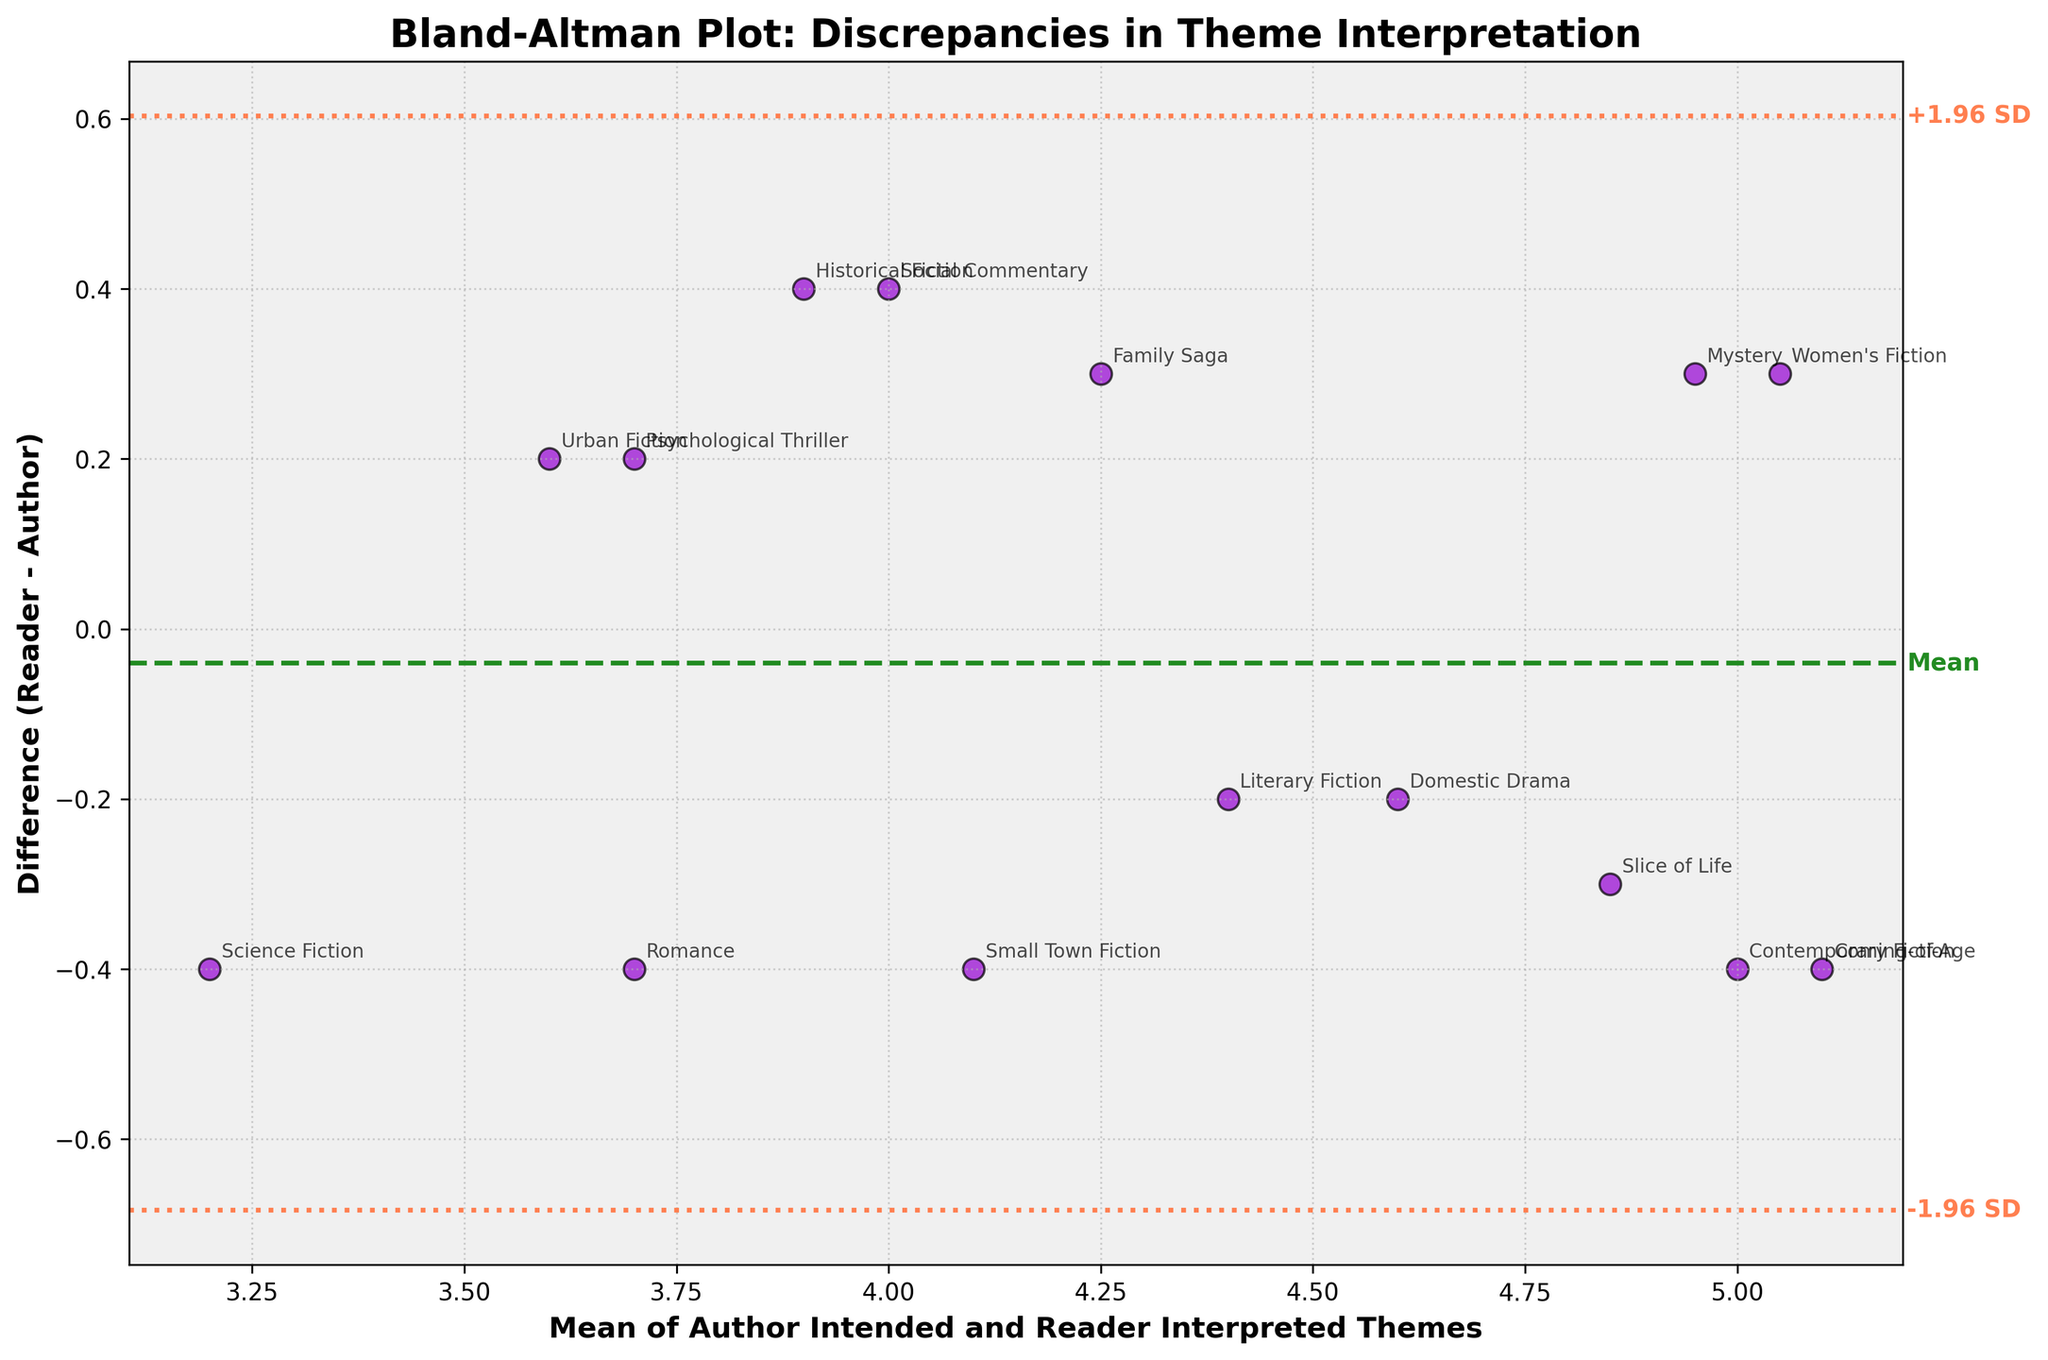What is the title of the Bland-Altman plot? The title of the Bland-Altman plot appears at the top center and is written in a large, bold font. By looking directly at the center top, you can read the full title of the plot.
Answer: Bland-Altman Plot: Discrepancies in Theme Interpretation What does the x-axis represent in the plot? The x-axis is labeled, and by reading the label, we can understand what it represents. The label is "Mean of Author Intended and Reader Interpreted Themes," indicating it shows the average value between the author's intended theme score and the reader's interpreted theme score.
Answer: Mean of Author Intended and Reader Interpreted Themes How many genres are represented in the plot? Each point on the plot represents a genre, and there are annotations next to each point specifying the genre name. By counting these annotations, we can determine the number of different genres represented.
Answer: 15 Which genre shows the largest difference between the author’s intended theme and the reader’s interpreted theme? To find the genre with the maximum difference, look for the data point that is farthest from the zero line on the plot in the vertical direction. The annotation next to this point reveals the genre.
Answer: Women's Fiction What is the mean difference (MD) line in this plot? The Mean Difference (MD) line is a horizontal line at the mean value of the differences between the author’s and reader’s theme scores. This value is indicated by the green dashed line and labeled on the plot.
Answer: MD (Mean Difference) is shown by the green dashed line What are the limits of agreement in the plot? The limits of agreement are the dashed lines that show MD ± 1.96*SD above and below the mean difference line. They are drawn in coral color and marked "+1.96 SD" and "-1.96 SD." These lines indicate the range within which most differences lie.
Answer: MD ± 1.96*SD Compare the differences in theme interpretation between Contemporary Fiction and Romance. To compare these genres, look for their annotations on the plot, and observe their vertical positions (differences). Contemporary Fiction has a small negative difference, while Romance has a slightly larger negative difference.
Answer: Romance has a larger negative difference than Contemporary Fiction Which genres have reader-interpreted themes that are, on average, higher than the author-intended themes? To find these genres, look for points above the zero difference line. The genres annotated next to these points show where readers interpreted the themes higher than the authors intended.
Answer: Historical Fiction, Mystery, Family Saga, Psychological Thriller, Social Commentary, Urban Fiction, Women's Fiction What is the standard deviation (SD) of the differences in the plot? The standard deviation (SD) is calculated and used to find the limits of agreement. Since these are shown as MD ± 1.96*SD, we can deduce the SD by dividing the range between these limits by 3.92. The coral lines are labeled, and the values can be used for this calculation.
Answer: Approx. 0.366 